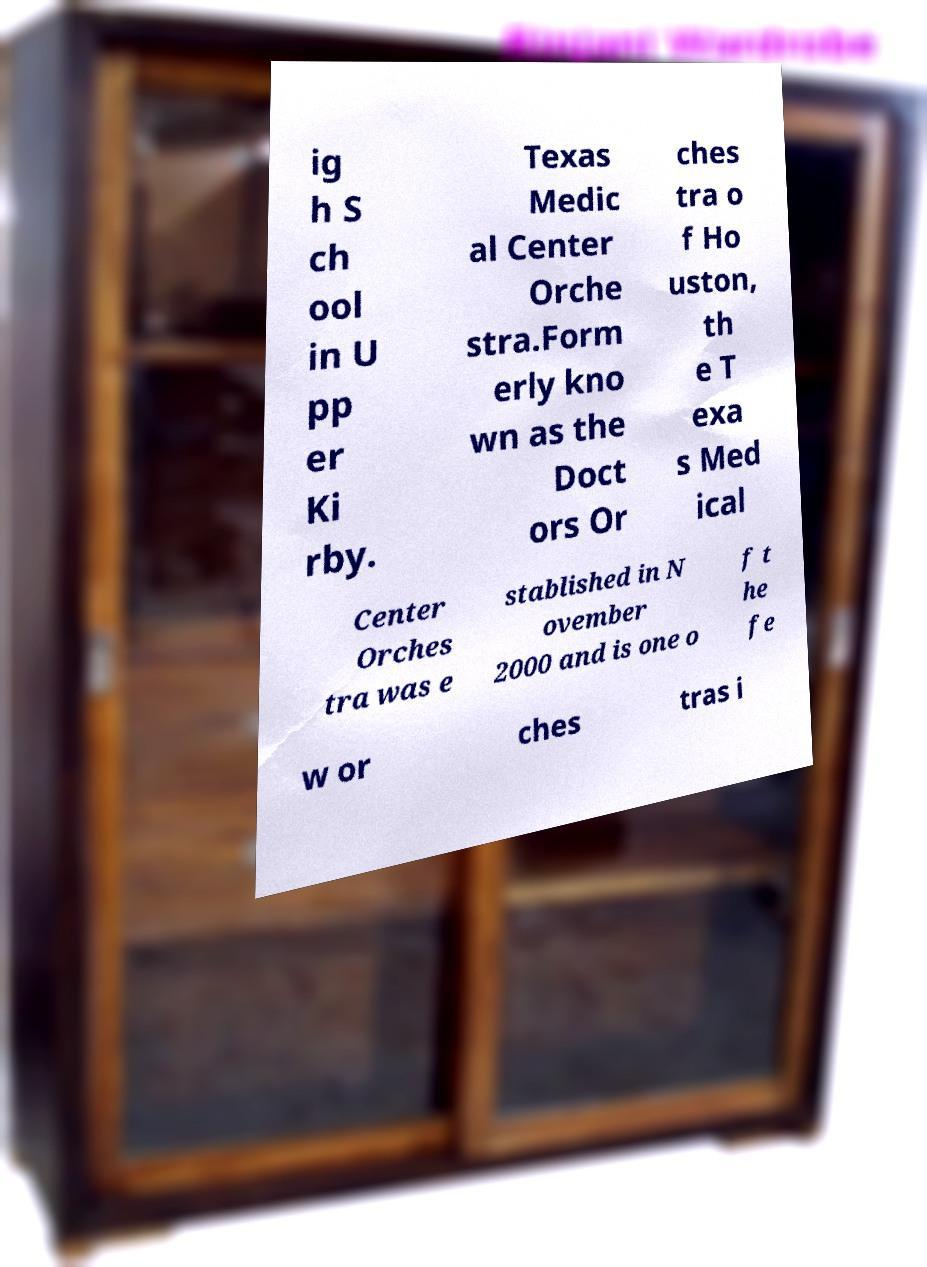There's text embedded in this image that I need extracted. Can you transcribe it verbatim? ig h S ch ool in U pp er Ki rby. Texas Medic al Center Orche stra.Form erly kno wn as the Doct ors Or ches tra o f Ho uston, th e T exa s Med ical Center Orches tra was e stablished in N ovember 2000 and is one o f t he fe w or ches tras i 